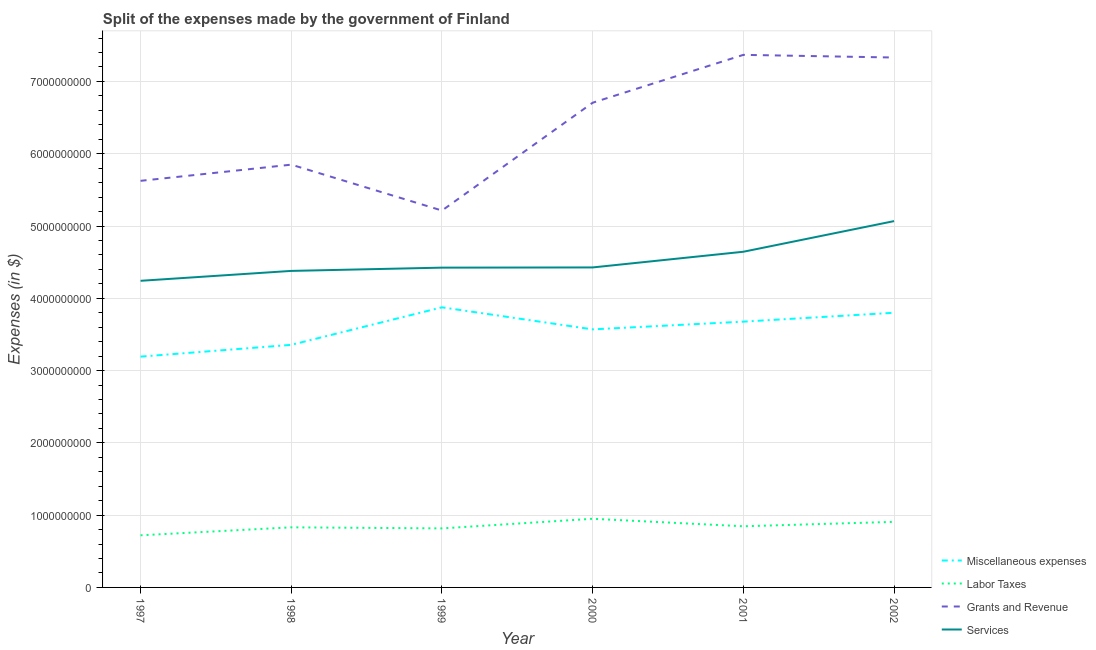How many different coloured lines are there?
Offer a very short reply. 4. What is the amount spent on miscellaneous expenses in 2001?
Provide a succinct answer. 3.68e+09. Across all years, what is the maximum amount spent on labor taxes?
Provide a succinct answer. 9.50e+08. Across all years, what is the minimum amount spent on miscellaneous expenses?
Offer a terse response. 3.19e+09. In which year was the amount spent on miscellaneous expenses maximum?
Ensure brevity in your answer.  1999. In which year was the amount spent on miscellaneous expenses minimum?
Make the answer very short. 1997. What is the total amount spent on services in the graph?
Keep it short and to the point. 2.72e+1. What is the difference between the amount spent on grants and revenue in 1999 and that in 2002?
Provide a succinct answer. -2.12e+09. What is the difference between the amount spent on services in 1997 and the amount spent on grants and revenue in 1998?
Your response must be concise. -1.61e+09. What is the average amount spent on labor taxes per year?
Keep it short and to the point. 8.45e+08. In the year 1999, what is the difference between the amount spent on miscellaneous expenses and amount spent on grants and revenue?
Your answer should be very brief. -1.34e+09. In how many years, is the amount spent on miscellaneous expenses greater than 4800000000 $?
Your response must be concise. 0. What is the ratio of the amount spent on grants and revenue in 1999 to that in 2000?
Provide a succinct answer. 0.78. What is the difference between the highest and the second highest amount spent on grants and revenue?
Keep it short and to the point. 3.70e+07. What is the difference between the highest and the lowest amount spent on grants and revenue?
Your answer should be compact. 2.15e+09. Is the sum of the amount spent on services in 1998 and 1999 greater than the maximum amount spent on labor taxes across all years?
Your answer should be very brief. Yes. Is it the case that in every year, the sum of the amount spent on miscellaneous expenses and amount spent on grants and revenue is greater than the sum of amount spent on services and amount spent on labor taxes?
Keep it short and to the point. Yes. Is it the case that in every year, the sum of the amount spent on miscellaneous expenses and amount spent on labor taxes is greater than the amount spent on grants and revenue?
Keep it short and to the point. No. Does the amount spent on miscellaneous expenses monotonically increase over the years?
Make the answer very short. No. How many lines are there?
Ensure brevity in your answer.  4. How many years are there in the graph?
Ensure brevity in your answer.  6. Does the graph contain grids?
Provide a short and direct response. Yes. What is the title of the graph?
Offer a very short reply. Split of the expenses made by the government of Finland. What is the label or title of the Y-axis?
Provide a short and direct response. Expenses (in $). What is the Expenses (in $) in Miscellaneous expenses in 1997?
Your answer should be very brief. 3.19e+09. What is the Expenses (in $) in Labor Taxes in 1997?
Your answer should be compact. 7.21e+08. What is the Expenses (in $) in Grants and Revenue in 1997?
Make the answer very short. 5.62e+09. What is the Expenses (in $) of Services in 1997?
Your answer should be very brief. 4.24e+09. What is the Expenses (in $) in Miscellaneous expenses in 1998?
Keep it short and to the point. 3.36e+09. What is the Expenses (in $) of Labor Taxes in 1998?
Make the answer very short. 8.31e+08. What is the Expenses (in $) in Grants and Revenue in 1998?
Ensure brevity in your answer.  5.85e+09. What is the Expenses (in $) of Services in 1998?
Your answer should be very brief. 4.38e+09. What is the Expenses (in $) in Miscellaneous expenses in 1999?
Your answer should be very brief. 3.88e+09. What is the Expenses (in $) of Labor Taxes in 1999?
Your answer should be compact. 8.17e+08. What is the Expenses (in $) in Grants and Revenue in 1999?
Make the answer very short. 5.21e+09. What is the Expenses (in $) of Services in 1999?
Provide a short and direct response. 4.42e+09. What is the Expenses (in $) of Miscellaneous expenses in 2000?
Your response must be concise. 3.57e+09. What is the Expenses (in $) in Labor Taxes in 2000?
Your response must be concise. 9.50e+08. What is the Expenses (in $) in Grants and Revenue in 2000?
Your answer should be very brief. 6.71e+09. What is the Expenses (in $) of Services in 2000?
Make the answer very short. 4.43e+09. What is the Expenses (in $) in Miscellaneous expenses in 2001?
Make the answer very short. 3.68e+09. What is the Expenses (in $) in Labor Taxes in 2001?
Offer a terse response. 8.46e+08. What is the Expenses (in $) of Grants and Revenue in 2001?
Give a very brief answer. 7.37e+09. What is the Expenses (in $) of Services in 2001?
Your response must be concise. 4.64e+09. What is the Expenses (in $) of Miscellaneous expenses in 2002?
Offer a very short reply. 3.80e+09. What is the Expenses (in $) in Labor Taxes in 2002?
Keep it short and to the point. 9.07e+08. What is the Expenses (in $) in Grants and Revenue in 2002?
Give a very brief answer. 7.33e+09. What is the Expenses (in $) of Services in 2002?
Your answer should be compact. 5.07e+09. Across all years, what is the maximum Expenses (in $) in Miscellaneous expenses?
Offer a terse response. 3.88e+09. Across all years, what is the maximum Expenses (in $) in Labor Taxes?
Offer a very short reply. 9.50e+08. Across all years, what is the maximum Expenses (in $) in Grants and Revenue?
Your response must be concise. 7.37e+09. Across all years, what is the maximum Expenses (in $) of Services?
Your response must be concise. 5.07e+09. Across all years, what is the minimum Expenses (in $) in Miscellaneous expenses?
Ensure brevity in your answer.  3.19e+09. Across all years, what is the minimum Expenses (in $) in Labor Taxes?
Provide a short and direct response. 7.21e+08. Across all years, what is the minimum Expenses (in $) of Grants and Revenue?
Your answer should be compact. 5.21e+09. Across all years, what is the minimum Expenses (in $) in Services?
Make the answer very short. 4.24e+09. What is the total Expenses (in $) of Miscellaneous expenses in the graph?
Offer a very short reply. 2.15e+1. What is the total Expenses (in $) of Labor Taxes in the graph?
Your response must be concise. 5.07e+09. What is the total Expenses (in $) in Grants and Revenue in the graph?
Give a very brief answer. 3.81e+1. What is the total Expenses (in $) of Services in the graph?
Your answer should be very brief. 2.72e+1. What is the difference between the Expenses (in $) in Miscellaneous expenses in 1997 and that in 1998?
Ensure brevity in your answer.  -1.63e+08. What is the difference between the Expenses (in $) of Labor Taxes in 1997 and that in 1998?
Give a very brief answer. -1.10e+08. What is the difference between the Expenses (in $) in Grants and Revenue in 1997 and that in 1998?
Your answer should be compact. -2.24e+08. What is the difference between the Expenses (in $) in Services in 1997 and that in 1998?
Your answer should be very brief. -1.37e+08. What is the difference between the Expenses (in $) in Miscellaneous expenses in 1997 and that in 1999?
Make the answer very short. -6.82e+08. What is the difference between the Expenses (in $) of Labor Taxes in 1997 and that in 1999?
Offer a very short reply. -9.55e+07. What is the difference between the Expenses (in $) of Grants and Revenue in 1997 and that in 1999?
Give a very brief answer. 4.11e+08. What is the difference between the Expenses (in $) in Services in 1997 and that in 1999?
Offer a very short reply. -1.82e+08. What is the difference between the Expenses (in $) of Miscellaneous expenses in 1997 and that in 2000?
Your answer should be very brief. -3.77e+08. What is the difference between the Expenses (in $) in Labor Taxes in 1997 and that in 2000?
Your answer should be very brief. -2.29e+08. What is the difference between the Expenses (in $) of Grants and Revenue in 1997 and that in 2000?
Offer a very short reply. -1.08e+09. What is the difference between the Expenses (in $) in Services in 1997 and that in 2000?
Offer a terse response. -1.85e+08. What is the difference between the Expenses (in $) of Miscellaneous expenses in 1997 and that in 2001?
Ensure brevity in your answer.  -4.84e+08. What is the difference between the Expenses (in $) in Labor Taxes in 1997 and that in 2001?
Keep it short and to the point. -1.25e+08. What is the difference between the Expenses (in $) in Grants and Revenue in 1997 and that in 2001?
Give a very brief answer. -1.74e+09. What is the difference between the Expenses (in $) in Services in 1997 and that in 2001?
Offer a very short reply. -4.02e+08. What is the difference between the Expenses (in $) in Miscellaneous expenses in 1997 and that in 2002?
Your response must be concise. -6.07e+08. What is the difference between the Expenses (in $) of Labor Taxes in 1997 and that in 2002?
Give a very brief answer. -1.86e+08. What is the difference between the Expenses (in $) of Grants and Revenue in 1997 and that in 2002?
Offer a very short reply. -1.71e+09. What is the difference between the Expenses (in $) in Services in 1997 and that in 2002?
Ensure brevity in your answer.  -8.26e+08. What is the difference between the Expenses (in $) of Miscellaneous expenses in 1998 and that in 1999?
Provide a short and direct response. -5.19e+08. What is the difference between the Expenses (in $) in Labor Taxes in 1998 and that in 1999?
Keep it short and to the point. 1.47e+07. What is the difference between the Expenses (in $) in Grants and Revenue in 1998 and that in 1999?
Give a very brief answer. 6.35e+08. What is the difference between the Expenses (in $) in Services in 1998 and that in 1999?
Your answer should be very brief. -4.50e+07. What is the difference between the Expenses (in $) of Miscellaneous expenses in 1998 and that in 2000?
Make the answer very short. -2.14e+08. What is the difference between the Expenses (in $) of Labor Taxes in 1998 and that in 2000?
Make the answer very short. -1.18e+08. What is the difference between the Expenses (in $) in Grants and Revenue in 1998 and that in 2000?
Ensure brevity in your answer.  -8.57e+08. What is the difference between the Expenses (in $) of Services in 1998 and that in 2000?
Give a very brief answer. -4.80e+07. What is the difference between the Expenses (in $) of Miscellaneous expenses in 1998 and that in 2001?
Offer a terse response. -3.21e+08. What is the difference between the Expenses (in $) of Labor Taxes in 1998 and that in 2001?
Provide a short and direct response. -1.46e+07. What is the difference between the Expenses (in $) in Grants and Revenue in 1998 and that in 2001?
Provide a succinct answer. -1.52e+09. What is the difference between the Expenses (in $) of Services in 1998 and that in 2001?
Ensure brevity in your answer.  -2.65e+08. What is the difference between the Expenses (in $) in Miscellaneous expenses in 1998 and that in 2002?
Give a very brief answer. -4.44e+08. What is the difference between the Expenses (in $) in Labor Taxes in 1998 and that in 2002?
Provide a succinct answer. -7.56e+07. What is the difference between the Expenses (in $) of Grants and Revenue in 1998 and that in 2002?
Provide a succinct answer. -1.48e+09. What is the difference between the Expenses (in $) of Services in 1998 and that in 2002?
Provide a short and direct response. -6.89e+08. What is the difference between the Expenses (in $) in Miscellaneous expenses in 1999 and that in 2000?
Your answer should be very brief. 3.05e+08. What is the difference between the Expenses (in $) in Labor Taxes in 1999 and that in 2000?
Give a very brief answer. -1.33e+08. What is the difference between the Expenses (in $) of Grants and Revenue in 1999 and that in 2000?
Your answer should be compact. -1.49e+09. What is the difference between the Expenses (in $) of Services in 1999 and that in 2000?
Your answer should be very brief. -3.00e+06. What is the difference between the Expenses (in $) of Miscellaneous expenses in 1999 and that in 2001?
Your answer should be very brief. 1.98e+08. What is the difference between the Expenses (in $) of Labor Taxes in 1999 and that in 2001?
Your response must be concise. -2.93e+07. What is the difference between the Expenses (in $) in Grants and Revenue in 1999 and that in 2001?
Offer a very short reply. -2.15e+09. What is the difference between the Expenses (in $) in Services in 1999 and that in 2001?
Your answer should be compact. -2.20e+08. What is the difference between the Expenses (in $) in Miscellaneous expenses in 1999 and that in 2002?
Make the answer very short. 7.50e+07. What is the difference between the Expenses (in $) of Labor Taxes in 1999 and that in 2002?
Keep it short and to the point. -9.03e+07. What is the difference between the Expenses (in $) of Grants and Revenue in 1999 and that in 2002?
Your answer should be compact. -2.12e+09. What is the difference between the Expenses (in $) of Services in 1999 and that in 2002?
Provide a succinct answer. -6.44e+08. What is the difference between the Expenses (in $) of Miscellaneous expenses in 2000 and that in 2001?
Ensure brevity in your answer.  -1.07e+08. What is the difference between the Expenses (in $) in Labor Taxes in 2000 and that in 2001?
Your response must be concise. 1.04e+08. What is the difference between the Expenses (in $) in Grants and Revenue in 2000 and that in 2001?
Provide a succinct answer. -6.62e+08. What is the difference between the Expenses (in $) in Services in 2000 and that in 2001?
Keep it short and to the point. -2.17e+08. What is the difference between the Expenses (in $) of Miscellaneous expenses in 2000 and that in 2002?
Your answer should be compact. -2.30e+08. What is the difference between the Expenses (in $) in Labor Taxes in 2000 and that in 2002?
Your answer should be compact. 4.28e+07. What is the difference between the Expenses (in $) of Grants and Revenue in 2000 and that in 2002?
Give a very brief answer. -6.25e+08. What is the difference between the Expenses (in $) of Services in 2000 and that in 2002?
Give a very brief answer. -6.41e+08. What is the difference between the Expenses (in $) of Miscellaneous expenses in 2001 and that in 2002?
Provide a short and direct response. -1.23e+08. What is the difference between the Expenses (in $) in Labor Taxes in 2001 and that in 2002?
Your response must be concise. -6.10e+07. What is the difference between the Expenses (in $) in Grants and Revenue in 2001 and that in 2002?
Offer a terse response. 3.70e+07. What is the difference between the Expenses (in $) in Services in 2001 and that in 2002?
Give a very brief answer. -4.24e+08. What is the difference between the Expenses (in $) of Miscellaneous expenses in 1997 and the Expenses (in $) of Labor Taxes in 1998?
Your answer should be very brief. 2.36e+09. What is the difference between the Expenses (in $) of Miscellaneous expenses in 1997 and the Expenses (in $) of Grants and Revenue in 1998?
Make the answer very short. -2.66e+09. What is the difference between the Expenses (in $) in Miscellaneous expenses in 1997 and the Expenses (in $) in Services in 1998?
Provide a short and direct response. -1.19e+09. What is the difference between the Expenses (in $) of Labor Taxes in 1997 and the Expenses (in $) of Grants and Revenue in 1998?
Your answer should be very brief. -5.13e+09. What is the difference between the Expenses (in $) of Labor Taxes in 1997 and the Expenses (in $) of Services in 1998?
Ensure brevity in your answer.  -3.66e+09. What is the difference between the Expenses (in $) of Grants and Revenue in 1997 and the Expenses (in $) of Services in 1998?
Ensure brevity in your answer.  1.25e+09. What is the difference between the Expenses (in $) of Miscellaneous expenses in 1997 and the Expenses (in $) of Labor Taxes in 1999?
Your answer should be very brief. 2.38e+09. What is the difference between the Expenses (in $) of Miscellaneous expenses in 1997 and the Expenses (in $) of Grants and Revenue in 1999?
Your answer should be very brief. -2.02e+09. What is the difference between the Expenses (in $) in Miscellaneous expenses in 1997 and the Expenses (in $) in Services in 1999?
Your response must be concise. -1.23e+09. What is the difference between the Expenses (in $) of Labor Taxes in 1997 and the Expenses (in $) of Grants and Revenue in 1999?
Keep it short and to the point. -4.49e+09. What is the difference between the Expenses (in $) in Labor Taxes in 1997 and the Expenses (in $) in Services in 1999?
Offer a very short reply. -3.70e+09. What is the difference between the Expenses (in $) in Grants and Revenue in 1997 and the Expenses (in $) in Services in 1999?
Offer a terse response. 1.20e+09. What is the difference between the Expenses (in $) of Miscellaneous expenses in 1997 and the Expenses (in $) of Labor Taxes in 2000?
Provide a succinct answer. 2.24e+09. What is the difference between the Expenses (in $) in Miscellaneous expenses in 1997 and the Expenses (in $) in Grants and Revenue in 2000?
Offer a very short reply. -3.51e+09. What is the difference between the Expenses (in $) in Miscellaneous expenses in 1997 and the Expenses (in $) in Services in 2000?
Keep it short and to the point. -1.23e+09. What is the difference between the Expenses (in $) of Labor Taxes in 1997 and the Expenses (in $) of Grants and Revenue in 2000?
Ensure brevity in your answer.  -5.98e+09. What is the difference between the Expenses (in $) of Labor Taxes in 1997 and the Expenses (in $) of Services in 2000?
Your answer should be compact. -3.71e+09. What is the difference between the Expenses (in $) in Grants and Revenue in 1997 and the Expenses (in $) in Services in 2000?
Your answer should be very brief. 1.20e+09. What is the difference between the Expenses (in $) of Miscellaneous expenses in 1997 and the Expenses (in $) of Labor Taxes in 2001?
Your response must be concise. 2.35e+09. What is the difference between the Expenses (in $) of Miscellaneous expenses in 1997 and the Expenses (in $) of Grants and Revenue in 2001?
Keep it short and to the point. -4.18e+09. What is the difference between the Expenses (in $) of Miscellaneous expenses in 1997 and the Expenses (in $) of Services in 2001?
Offer a terse response. -1.45e+09. What is the difference between the Expenses (in $) of Labor Taxes in 1997 and the Expenses (in $) of Grants and Revenue in 2001?
Provide a succinct answer. -6.65e+09. What is the difference between the Expenses (in $) in Labor Taxes in 1997 and the Expenses (in $) in Services in 2001?
Give a very brief answer. -3.92e+09. What is the difference between the Expenses (in $) of Grants and Revenue in 1997 and the Expenses (in $) of Services in 2001?
Ensure brevity in your answer.  9.81e+08. What is the difference between the Expenses (in $) of Miscellaneous expenses in 1997 and the Expenses (in $) of Labor Taxes in 2002?
Your answer should be very brief. 2.29e+09. What is the difference between the Expenses (in $) in Miscellaneous expenses in 1997 and the Expenses (in $) in Grants and Revenue in 2002?
Your response must be concise. -4.14e+09. What is the difference between the Expenses (in $) of Miscellaneous expenses in 1997 and the Expenses (in $) of Services in 2002?
Your answer should be very brief. -1.88e+09. What is the difference between the Expenses (in $) of Labor Taxes in 1997 and the Expenses (in $) of Grants and Revenue in 2002?
Provide a succinct answer. -6.61e+09. What is the difference between the Expenses (in $) in Labor Taxes in 1997 and the Expenses (in $) in Services in 2002?
Offer a terse response. -4.35e+09. What is the difference between the Expenses (in $) in Grants and Revenue in 1997 and the Expenses (in $) in Services in 2002?
Offer a very short reply. 5.57e+08. What is the difference between the Expenses (in $) in Miscellaneous expenses in 1998 and the Expenses (in $) in Labor Taxes in 1999?
Offer a terse response. 2.54e+09. What is the difference between the Expenses (in $) in Miscellaneous expenses in 1998 and the Expenses (in $) in Grants and Revenue in 1999?
Offer a terse response. -1.86e+09. What is the difference between the Expenses (in $) in Miscellaneous expenses in 1998 and the Expenses (in $) in Services in 1999?
Your answer should be very brief. -1.07e+09. What is the difference between the Expenses (in $) of Labor Taxes in 1998 and the Expenses (in $) of Grants and Revenue in 1999?
Your response must be concise. -4.38e+09. What is the difference between the Expenses (in $) in Labor Taxes in 1998 and the Expenses (in $) in Services in 1999?
Ensure brevity in your answer.  -3.59e+09. What is the difference between the Expenses (in $) of Grants and Revenue in 1998 and the Expenses (in $) of Services in 1999?
Keep it short and to the point. 1.42e+09. What is the difference between the Expenses (in $) in Miscellaneous expenses in 1998 and the Expenses (in $) in Labor Taxes in 2000?
Your response must be concise. 2.41e+09. What is the difference between the Expenses (in $) of Miscellaneous expenses in 1998 and the Expenses (in $) of Grants and Revenue in 2000?
Ensure brevity in your answer.  -3.35e+09. What is the difference between the Expenses (in $) in Miscellaneous expenses in 1998 and the Expenses (in $) in Services in 2000?
Offer a very short reply. -1.07e+09. What is the difference between the Expenses (in $) in Labor Taxes in 1998 and the Expenses (in $) in Grants and Revenue in 2000?
Your answer should be very brief. -5.87e+09. What is the difference between the Expenses (in $) in Labor Taxes in 1998 and the Expenses (in $) in Services in 2000?
Offer a terse response. -3.60e+09. What is the difference between the Expenses (in $) of Grants and Revenue in 1998 and the Expenses (in $) of Services in 2000?
Make the answer very short. 1.42e+09. What is the difference between the Expenses (in $) of Miscellaneous expenses in 1998 and the Expenses (in $) of Labor Taxes in 2001?
Your answer should be compact. 2.51e+09. What is the difference between the Expenses (in $) of Miscellaneous expenses in 1998 and the Expenses (in $) of Grants and Revenue in 2001?
Make the answer very short. -4.01e+09. What is the difference between the Expenses (in $) in Miscellaneous expenses in 1998 and the Expenses (in $) in Services in 2001?
Provide a short and direct response. -1.29e+09. What is the difference between the Expenses (in $) of Labor Taxes in 1998 and the Expenses (in $) of Grants and Revenue in 2001?
Provide a short and direct response. -6.54e+09. What is the difference between the Expenses (in $) of Labor Taxes in 1998 and the Expenses (in $) of Services in 2001?
Ensure brevity in your answer.  -3.81e+09. What is the difference between the Expenses (in $) of Grants and Revenue in 1998 and the Expenses (in $) of Services in 2001?
Ensure brevity in your answer.  1.20e+09. What is the difference between the Expenses (in $) of Miscellaneous expenses in 1998 and the Expenses (in $) of Labor Taxes in 2002?
Your answer should be compact. 2.45e+09. What is the difference between the Expenses (in $) of Miscellaneous expenses in 1998 and the Expenses (in $) of Grants and Revenue in 2002?
Ensure brevity in your answer.  -3.98e+09. What is the difference between the Expenses (in $) in Miscellaneous expenses in 1998 and the Expenses (in $) in Services in 2002?
Offer a terse response. -1.71e+09. What is the difference between the Expenses (in $) in Labor Taxes in 1998 and the Expenses (in $) in Grants and Revenue in 2002?
Your answer should be very brief. -6.50e+09. What is the difference between the Expenses (in $) of Labor Taxes in 1998 and the Expenses (in $) of Services in 2002?
Give a very brief answer. -4.24e+09. What is the difference between the Expenses (in $) in Grants and Revenue in 1998 and the Expenses (in $) in Services in 2002?
Your answer should be very brief. 7.81e+08. What is the difference between the Expenses (in $) in Miscellaneous expenses in 1999 and the Expenses (in $) in Labor Taxes in 2000?
Provide a short and direct response. 2.93e+09. What is the difference between the Expenses (in $) of Miscellaneous expenses in 1999 and the Expenses (in $) of Grants and Revenue in 2000?
Provide a short and direct response. -2.83e+09. What is the difference between the Expenses (in $) in Miscellaneous expenses in 1999 and the Expenses (in $) in Services in 2000?
Give a very brief answer. -5.52e+08. What is the difference between the Expenses (in $) in Labor Taxes in 1999 and the Expenses (in $) in Grants and Revenue in 2000?
Provide a short and direct response. -5.89e+09. What is the difference between the Expenses (in $) in Labor Taxes in 1999 and the Expenses (in $) in Services in 2000?
Give a very brief answer. -3.61e+09. What is the difference between the Expenses (in $) in Grants and Revenue in 1999 and the Expenses (in $) in Services in 2000?
Keep it short and to the point. 7.87e+08. What is the difference between the Expenses (in $) in Miscellaneous expenses in 1999 and the Expenses (in $) in Labor Taxes in 2001?
Provide a succinct answer. 3.03e+09. What is the difference between the Expenses (in $) of Miscellaneous expenses in 1999 and the Expenses (in $) of Grants and Revenue in 2001?
Make the answer very short. -3.49e+09. What is the difference between the Expenses (in $) of Miscellaneous expenses in 1999 and the Expenses (in $) of Services in 2001?
Ensure brevity in your answer.  -7.69e+08. What is the difference between the Expenses (in $) of Labor Taxes in 1999 and the Expenses (in $) of Grants and Revenue in 2001?
Your answer should be very brief. -6.55e+09. What is the difference between the Expenses (in $) in Labor Taxes in 1999 and the Expenses (in $) in Services in 2001?
Your response must be concise. -3.83e+09. What is the difference between the Expenses (in $) in Grants and Revenue in 1999 and the Expenses (in $) in Services in 2001?
Offer a very short reply. 5.70e+08. What is the difference between the Expenses (in $) in Miscellaneous expenses in 1999 and the Expenses (in $) in Labor Taxes in 2002?
Provide a succinct answer. 2.97e+09. What is the difference between the Expenses (in $) in Miscellaneous expenses in 1999 and the Expenses (in $) in Grants and Revenue in 2002?
Your answer should be very brief. -3.46e+09. What is the difference between the Expenses (in $) in Miscellaneous expenses in 1999 and the Expenses (in $) in Services in 2002?
Keep it short and to the point. -1.19e+09. What is the difference between the Expenses (in $) in Labor Taxes in 1999 and the Expenses (in $) in Grants and Revenue in 2002?
Keep it short and to the point. -6.51e+09. What is the difference between the Expenses (in $) of Labor Taxes in 1999 and the Expenses (in $) of Services in 2002?
Give a very brief answer. -4.25e+09. What is the difference between the Expenses (in $) in Grants and Revenue in 1999 and the Expenses (in $) in Services in 2002?
Your answer should be very brief. 1.46e+08. What is the difference between the Expenses (in $) in Miscellaneous expenses in 2000 and the Expenses (in $) in Labor Taxes in 2001?
Ensure brevity in your answer.  2.72e+09. What is the difference between the Expenses (in $) of Miscellaneous expenses in 2000 and the Expenses (in $) of Grants and Revenue in 2001?
Your response must be concise. -3.80e+09. What is the difference between the Expenses (in $) in Miscellaneous expenses in 2000 and the Expenses (in $) in Services in 2001?
Make the answer very short. -1.07e+09. What is the difference between the Expenses (in $) in Labor Taxes in 2000 and the Expenses (in $) in Grants and Revenue in 2001?
Give a very brief answer. -6.42e+09. What is the difference between the Expenses (in $) in Labor Taxes in 2000 and the Expenses (in $) in Services in 2001?
Offer a very short reply. -3.69e+09. What is the difference between the Expenses (in $) of Grants and Revenue in 2000 and the Expenses (in $) of Services in 2001?
Your answer should be compact. 2.06e+09. What is the difference between the Expenses (in $) in Miscellaneous expenses in 2000 and the Expenses (in $) in Labor Taxes in 2002?
Offer a very short reply. 2.66e+09. What is the difference between the Expenses (in $) in Miscellaneous expenses in 2000 and the Expenses (in $) in Grants and Revenue in 2002?
Offer a terse response. -3.76e+09. What is the difference between the Expenses (in $) of Miscellaneous expenses in 2000 and the Expenses (in $) of Services in 2002?
Keep it short and to the point. -1.50e+09. What is the difference between the Expenses (in $) of Labor Taxes in 2000 and the Expenses (in $) of Grants and Revenue in 2002?
Offer a very short reply. -6.38e+09. What is the difference between the Expenses (in $) in Labor Taxes in 2000 and the Expenses (in $) in Services in 2002?
Provide a succinct answer. -4.12e+09. What is the difference between the Expenses (in $) in Grants and Revenue in 2000 and the Expenses (in $) in Services in 2002?
Ensure brevity in your answer.  1.64e+09. What is the difference between the Expenses (in $) of Miscellaneous expenses in 2001 and the Expenses (in $) of Labor Taxes in 2002?
Your response must be concise. 2.77e+09. What is the difference between the Expenses (in $) of Miscellaneous expenses in 2001 and the Expenses (in $) of Grants and Revenue in 2002?
Offer a terse response. -3.65e+09. What is the difference between the Expenses (in $) of Miscellaneous expenses in 2001 and the Expenses (in $) of Services in 2002?
Ensure brevity in your answer.  -1.39e+09. What is the difference between the Expenses (in $) in Labor Taxes in 2001 and the Expenses (in $) in Grants and Revenue in 2002?
Make the answer very short. -6.49e+09. What is the difference between the Expenses (in $) in Labor Taxes in 2001 and the Expenses (in $) in Services in 2002?
Give a very brief answer. -4.22e+09. What is the difference between the Expenses (in $) in Grants and Revenue in 2001 and the Expenses (in $) in Services in 2002?
Your response must be concise. 2.30e+09. What is the average Expenses (in $) of Miscellaneous expenses per year?
Provide a short and direct response. 3.58e+09. What is the average Expenses (in $) in Labor Taxes per year?
Offer a very short reply. 8.45e+08. What is the average Expenses (in $) of Grants and Revenue per year?
Provide a short and direct response. 6.35e+09. What is the average Expenses (in $) in Services per year?
Offer a very short reply. 4.53e+09. In the year 1997, what is the difference between the Expenses (in $) of Miscellaneous expenses and Expenses (in $) of Labor Taxes?
Offer a terse response. 2.47e+09. In the year 1997, what is the difference between the Expenses (in $) of Miscellaneous expenses and Expenses (in $) of Grants and Revenue?
Your answer should be compact. -2.43e+09. In the year 1997, what is the difference between the Expenses (in $) in Miscellaneous expenses and Expenses (in $) in Services?
Your answer should be compact. -1.05e+09. In the year 1997, what is the difference between the Expenses (in $) of Labor Taxes and Expenses (in $) of Grants and Revenue?
Ensure brevity in your answer.  -4.90e+09. In the year 1997, what is the difference between the Expenses (in $) in Labor Taxes and Expenses (in $) in Services?
Your response must be concise. -3.52e+09. In the year 1997, what is the difference between the Expenses (in $) of Grants and Revenue and Expenses (in $) of Services?
Ensure brevity in your answer.  1.38e+09. In the year 1998, what is the difference between the Expenses (in $) in Miscellaneous expenses and Expenses (in $) in Labor Taxes?
Your answer should be very brief. 2.52e+09. In the year 1998, what is the difference between the Expenses (in $) of Miscellaneous expenses and Expenses (in $) of Grants and Revenue?
Offer a very short reply. -2.49e+09. In the year 1998, what is the difference between the Expenses (in $) in Miscellaneous expenses and Expenses (in $) in Services?
Your answer should be compact. -1.02e+09. In the year 1998, what is the difference between the Expenses (in $) of Labor Taxes and Expenses (in $) of Grants and Revenue?
Your answer should be compact. -5.02e+09. In the year 1998, what is the difference between the Expenses (in $) of Labor Taxes and Expenses (in $) of Services?
Ensure brevity in your answer.  -3.55e+09. In the year 1998, what is the difference between the Expenses (in $) in Grants and Revenue and Expenses (in $) in Services?
Your answer should be very brief. 1.47e+09. In the year 1999, what is the difference between the Expenses (in $) of Miscellaneous expenses and Expenses (in $) of Labor Taxes?
Provide a short and direct response. 3.06e+09. In the year 1999, what is the difference between the Expenses (in $) of Miscellaneous expenses and Expenses (in $) of Grants and Revenue?
Give a very brief answer. -1.34e+09. In the year 1999, what is the difference between the Expenses (in $) in Miscellaneous expenses and Expenses (in $) in Services?
Your answer should be compact. -5.49e+08. In the year 1999, what is the difference between the Expenses (in $) of Labor Taxes and Expenses (in $) of Grants and Revenue?
Provide a short and direct response. -4.40e+09. In the year 1999, what is the difference between the Expenses (in $) of Labor Taxes and Expenses (in $) of Services?
Your answer should be very brief. -3.61e+09. In the year 1999, what is the difference between the Expenses (in $) of Grants and Revenue and Expenses (in $) of Services?
Give a very brief answer. 7.90e+08. In the year 2000, what is the difference between the Expenses (in $) of Miscellaneous expenses and Expenses (in $) of Labor Taxes?
Ensure brevity in your answer.  2.62e+09. In the year 2000, what is the difference between the Expenses (in $) in Miscellaneous expenses and Expenses (in $) in Grants and Revenue?
Your answer should be very brief. -3.14e+09. In the year 2000, what is the difference between the Expenses (in $) in Miscellaneous expenses and Expenses (in $) in Services?
Offer a terse response. -8.57e+08. In the year 2000, what is the difference between the Expenses (in $) in Labor Taxes and Expenses (in $) in Grants and Revenue?
Your response must be concise. -5.76e+09. In the year 2000, what is the difference between the Expenses (in $) of Labor Taxes and Expenses (in $) of Services?
Give a very brief answer. -3.48e+09. In the year 2000, what is the difference between the Expenses (in $) of Grants and Revenue and Expenses (in $) of Services?
Ensure brevity in your answer.  2.28e+09. In the year 2001, what is the difference between the Expenses (in $) of Miscellaneous expenses and Expenses (in $) of Labor Taxes?
Provide a short and direct response. 2.83e+09. In the year 2001, what is the difference between the Expenses (in $) in Miscellaneous expenses and Expenses (in $) in Grants and Revenue?
Offer a very short reply. -3.69e+09. In the year 2001, what is the difference between the Expenses (in $) of Miscellaneous expenses and Expenses (in $) of Services?
Make the answer very short. -9.67e+08. In the year 2001, what is the difference between the Expenses (in $) of Labor Taxes and Expenses (in $) of Grants and Revenue?
Give a very brief answer. -6.52e+09. In the year 2001, what is the difference between the Expenses (in $) in Labor Taxes and Expenses (in $) in Services?
Ensure brevity in your answer.  -3.80e+09. In the year 2001, what is the difference between the Expenses (in $) in Grants and Revenue and Expenses (in $) in Services?
Ensure brevity in your answer.  2.72e+09. In the year 2002, what is the difference between the Expenses (in $) of Miscellaneous expenses and Expenses (in $) of Labor Taxes?
Offer a very short reply. 2.89e+09. In the year 2002, what is the difference between the Expenses (in $) of Miscellaneous expenses and Expenses (in $) of Grants and Revenue?
Keep it short and to the point. -3.53e+09. In the year 2002, what is the difference between the Expenses (in $) in Miscellaneous expenses and Expenses (in $) in Services?
Ensure brevity in your answer.  -1.27e+09. In the year 2002, what is the difference between the Expenses (in $) of Labor Taxes and Expenses (in $) of Grants and Revenue?
Ensure brevity in your answer.  -6.42e+09. In the year 2002, what is the difference between the Expenses (in $) of Labor Taxes and Expenses (in $) of Services?
Ensure brevity in your answer.  -4.16e+09. In the year 2002, what is the difference between the Expenses (in $) of Grants and Revenue and Expenses (in $) of Services?
Provide a short and direct response. 2.26e+09. What is the ratio of the Expenses (in $) in Miscellaneous expenses in 1997 to that in 1998?
Your answer should be compact. 0.95. What is the ratio of the Expenses (in $) in Labor Taxes in 1997 to that in 1998?
Give a very brief answer. 0.87. What is the ratio of the Expenses (in $) of Grants and Revenue in 1997 to that in 1998?
Your answer should be very brief. 0.96. What is the ratio of the Expenses (in $) of Services in 1997 to that in 1998?
Your answer should be very brief. 0.97. What is the ratio of the Expenses (in $) of Miscellaneous expenses in 1997 to that in 1999?
Make the answer very short. 0.82. What is the ratio of the Expenses (in $) in Labor Taxes in 1997 to that in 1999?
Make the answer very short. 0.88. What is the ratio of the Expenses (in $) of Grants and Revenue in 1997 to that in 1999?
Keep it short and to the point. 1.08. What is the ratio of the Expenses (in $) in Services in 1997 to that in 1999?
Offer a terse response. 0.96. What is the ratio of the Expenses (in $) in Miscellaneous expenses in 1997 to that in 2000?
Ensure brevity in your answer.  0.89. What is the ratio of the Expenses (in $) in Labor Taxes in 1997 to that in 2000?
Your answer should be compact. 0.76. What is the ratio of the Expenses (in $) in Grants and Revenue in 1997 to that in 2000?
Keep it short and to the point. 0.84. What is the ratio of the Expenses (in $) of Services in 1997 to that in 2000?
Provide a short and direct response. 0.96. What is the ratio of the Expenses (in $) in Miscellaneous expenses in 1997 to that in 2001?
Your answer should be compact. 0.87. What is the ratio of the Expenses (in $) in Labor Taxes in 1997 to that in 2001?
Your response must be concise. 0.85. What is the ratio of the Expenses (in $) of Grants and Revenue in 1997 to that in 2001?
Give a very brief answer. 0.76. What is the ratio of the Expenses (in $) of Services in 1997 to that in 2001?
Your answer should be compact. 0.91. What is the ratio of the Expenses (in $) of Miscellaneous expenses in 1997 to that in 2002?
Make the answer very short. 0.84. What is the ratio of the Expenses (in $) of Labor Taxes in 1997 to that in 2002?
Offer a very short reply. 0.8. What is the ratio of the Expenses (in $) of Grants and Revenue in 1997 to that in 2002?
Keep it short and to the point. 0.77. What is the ratio of the Expenses (in $) in Services in 1997 to that in 2002?
Your response must be concise. 0.84. What is the ratio of the Expenses (in $) in Miscellaneous expenses in 1998 to that in 1999?
Your response must be concise. 0.87. What is the ratio of the Expenses (in $) of Labor Taxes in 1998 to that in 1999?
Your answer should be compact. 1.02. What is the ratio of the Expenses (in $) in Grants and Revenue in 1998 to that in 1999?
Offer a terse response. 1.12. What is the ratio of the Expenses (in $) in Services in 1998 to that in 1999?
Your answer should be compact. 0.99. What is the ratio of the Expenses (in $) in Miscellaneous expenses in 1998 to that in 2000?
Offer a very short reply. 0.94. What is the ratio of the Expenses (in $) in Labor Taxes in 1998 to that in 2000?
Your answer should be compact. 0.88. What is the ratio of the Expenses (in $) in Grants and Revenue in 1998 to that in 2000?
Offer a terse response. 0.87. What is the ratio of the Expenses (in $) of Miscellaneous expenses in 1998 to that in 2001?
Give a very brief answer. 0.91. What is the ratio of the Expenses (in $) in Labor Taxes in 1998 to that in 2001?
Keep it short and to the point. 0.98. What is the ratio of the Expenses (in $) in Grants and Revenue in 1998 to that in 2001?
Provide a short and direct response. 0.79. What is the ratio of the Expenses (in $) in Services in 1998 to that in 2001?
Offer a very short reply. 0.94. What is the ratio of the Expenses (in $) in Miscellaneous expenses in 1998 to that in 2002?
Ensure brevity in your answer.  0.88. What is the ratio of the Expenses (in $) in Grants and Revenue in 1998 to that in 2002?
Provide a short and direct response. 0.8. What is the ratio of the Expenses (in $) in Services in 1998 to that in 2002?
Offer a terse response. 0.86. What is the ratio of the Expenses (in $) in Miscellaneous expenses in 1999 to that in 2000?
Give a very brief answer. 1.09. What is the ratio of the Expenses (in $) of Labor Taxes in 1999 to that in 2000?
Provide a short and direct response. 0.86. What is the ratio of the Expenses (in $) in Grants and Revenue in 1999 to that in 2000?
Give a very brief answer. 0.78. What is the ratio of the Expenses (in $) in Miscellaneous expenses in 1999 to that in 2001?
Offer a terse response. 1.05. What is the ratio of the Expenses (in $) of Labor Taxes in 1999 to that in 2001?
Offer a terse response. 0.97. What is the ratio of the Expenses (in $) in Grants and Revenue in 1999 to that in 2001?
Give a very brief answer. 0.71. What is the ratio of the Expenses (in $) in Services in 1999 to that in 2001?
Keep it short and to the point. 0.95. What is the ratio of the Expenses (in $) of Miscellaneous expenses in 1999 to that in 2002?
Offer a very short reply. 1.02. What is the ratio of the Expenses (in $) in Labor Taxes in 1999 to that in 2002?
Your response must be concise. 0.9. What is the ratio of the Expenses (in $) of Grants and Revenue in 1999 to that in 2002?
Offer a very short reply. 0.71. What is the ratio of the Expenses (in $) in Services in 1999 to that in 2002?
Give a very brief answer. 0.87. What is the ratio of the Expenses (in $) in Miscellaneous expenses in 2000 to that in 2001?
Your answer should be very brief. 0.97. What is the ratio of the Expenses (in $) in Labor Taxes in 2000 to that in 2001?
Make the answer very short. 1.12. What is the ratio of the Expenses (in $) of Grants and Revenue in 2000 to that in 2001?
Offer a terse response. 0.91. What is the ratio of the Expenses (in $) of Services in 2000 to that in 2001?
Keep it short and to the point. 0.95. What is the ratio of the Expenses (in $) of Miscellaneous expenses in 2000 to that in 2002?
Make the answer very short. 0.94. What is the ratio of the Expenses (in $) of Labor Taxes in 2000 to that in 2002?
Offer a terse response. 1.05. What is the ratio of the Expenses (in $) of Grants and Revenue in 2000 to that in 2002?
Your answer should be compact. 0.91. What is the ratio of the Expenses (in $) of Services in 2000 to that in 2002?
Your response must be concise. 0.87. What is the ratio of the Expenses (in $) in Miscellaneous expenses in 2001 to that in 2002?
Make the answer very short. 0.97. What is the ratio of the Expenses (in $) in Labor Taxes in 2001 to that in 2002?
Provide a short and direct response. 0.93. What is the ratio of the Expenses (in $) of Grants and Revenue in 2001 to that in 2002?
Your response must be concise. 1. What is the ratio of the Expenses (in $) of Services in 2001 to that in 2002?
Provide a short and direct response. 0.92. What is the difference between the highest and the second highest Expenses (in $) in Miscellaneous expenses?
Provide a succinct answer. 7.50e+07. What is the difference between the highest and the second highest Expenses (in $) of Labor Taxes?
Ensure brevity in your answer.  4.28e+07. What is the difference between the highest and the second highest Expenses (in $) in Grants and Revenue?
Ensure brevity in your answer.  3.70e+07. What is the difference between the highest and the second highest Expenses (in $) in Services?
Keep it short and to the point. 4.24e+08. What is the difference between the highest and the lowest Expenses (in $) in Miscellaneous expenses?
Your answer should be very brief. 6.82e+08. What is the difference between the highest and the lowest Expenses (in $) of Labor Taxes?
Offer a terse response. 2.29e+08. What is the difference between the highest and the lowest Expenses (in $) in Grants and Revenue?
Provide a succinct answer. 2.15e+09. What is the difference between the highest and the lowest Expenses (in $) of Services?
Offer a terse response. 8.26e+08. 